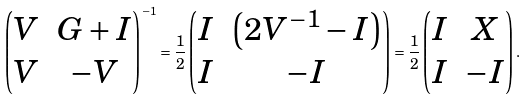Convert formula to latex. <formula><loc_0><loc_0><loc_500><loc_500>\begin{pmatrix} V & G + I \\ V & - V \end{pmatrix} ^ { - 1 } = \frac { 1 } { 2 } \begin{pmatrix} I & \left ( 2 V ^ { - 1 } - I \right ) \\ I & - I \end{pmatrix} = \frac { 1 } { 2 } \begin{pmatrix} I & X \\ I & - I \end{pmatrix} .</formula> 